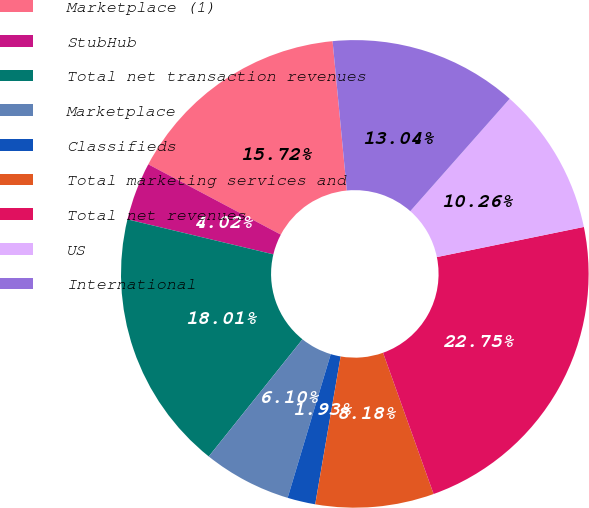Convert chart to OTSL. <chart><loc_0><loc_0><loc_500><loc_500><pie_chart><fcel>Marketplace (1)<fcel>StubHub<fcel>Total net transaction revenues<fcel>Marketplace<fcel>Classifieds<fcel>Total marketing services and<fcel>Total net revenues<fcel>US<fcel>International<nl><fcel>15.72%<fcel>4.02%<fcel>18.01%<fcel>6.1%<fcel>1.93%<fcel>8.18%<fcel>22.75%<fcel>10.26%<fcel>13.04%<nl></chart> 